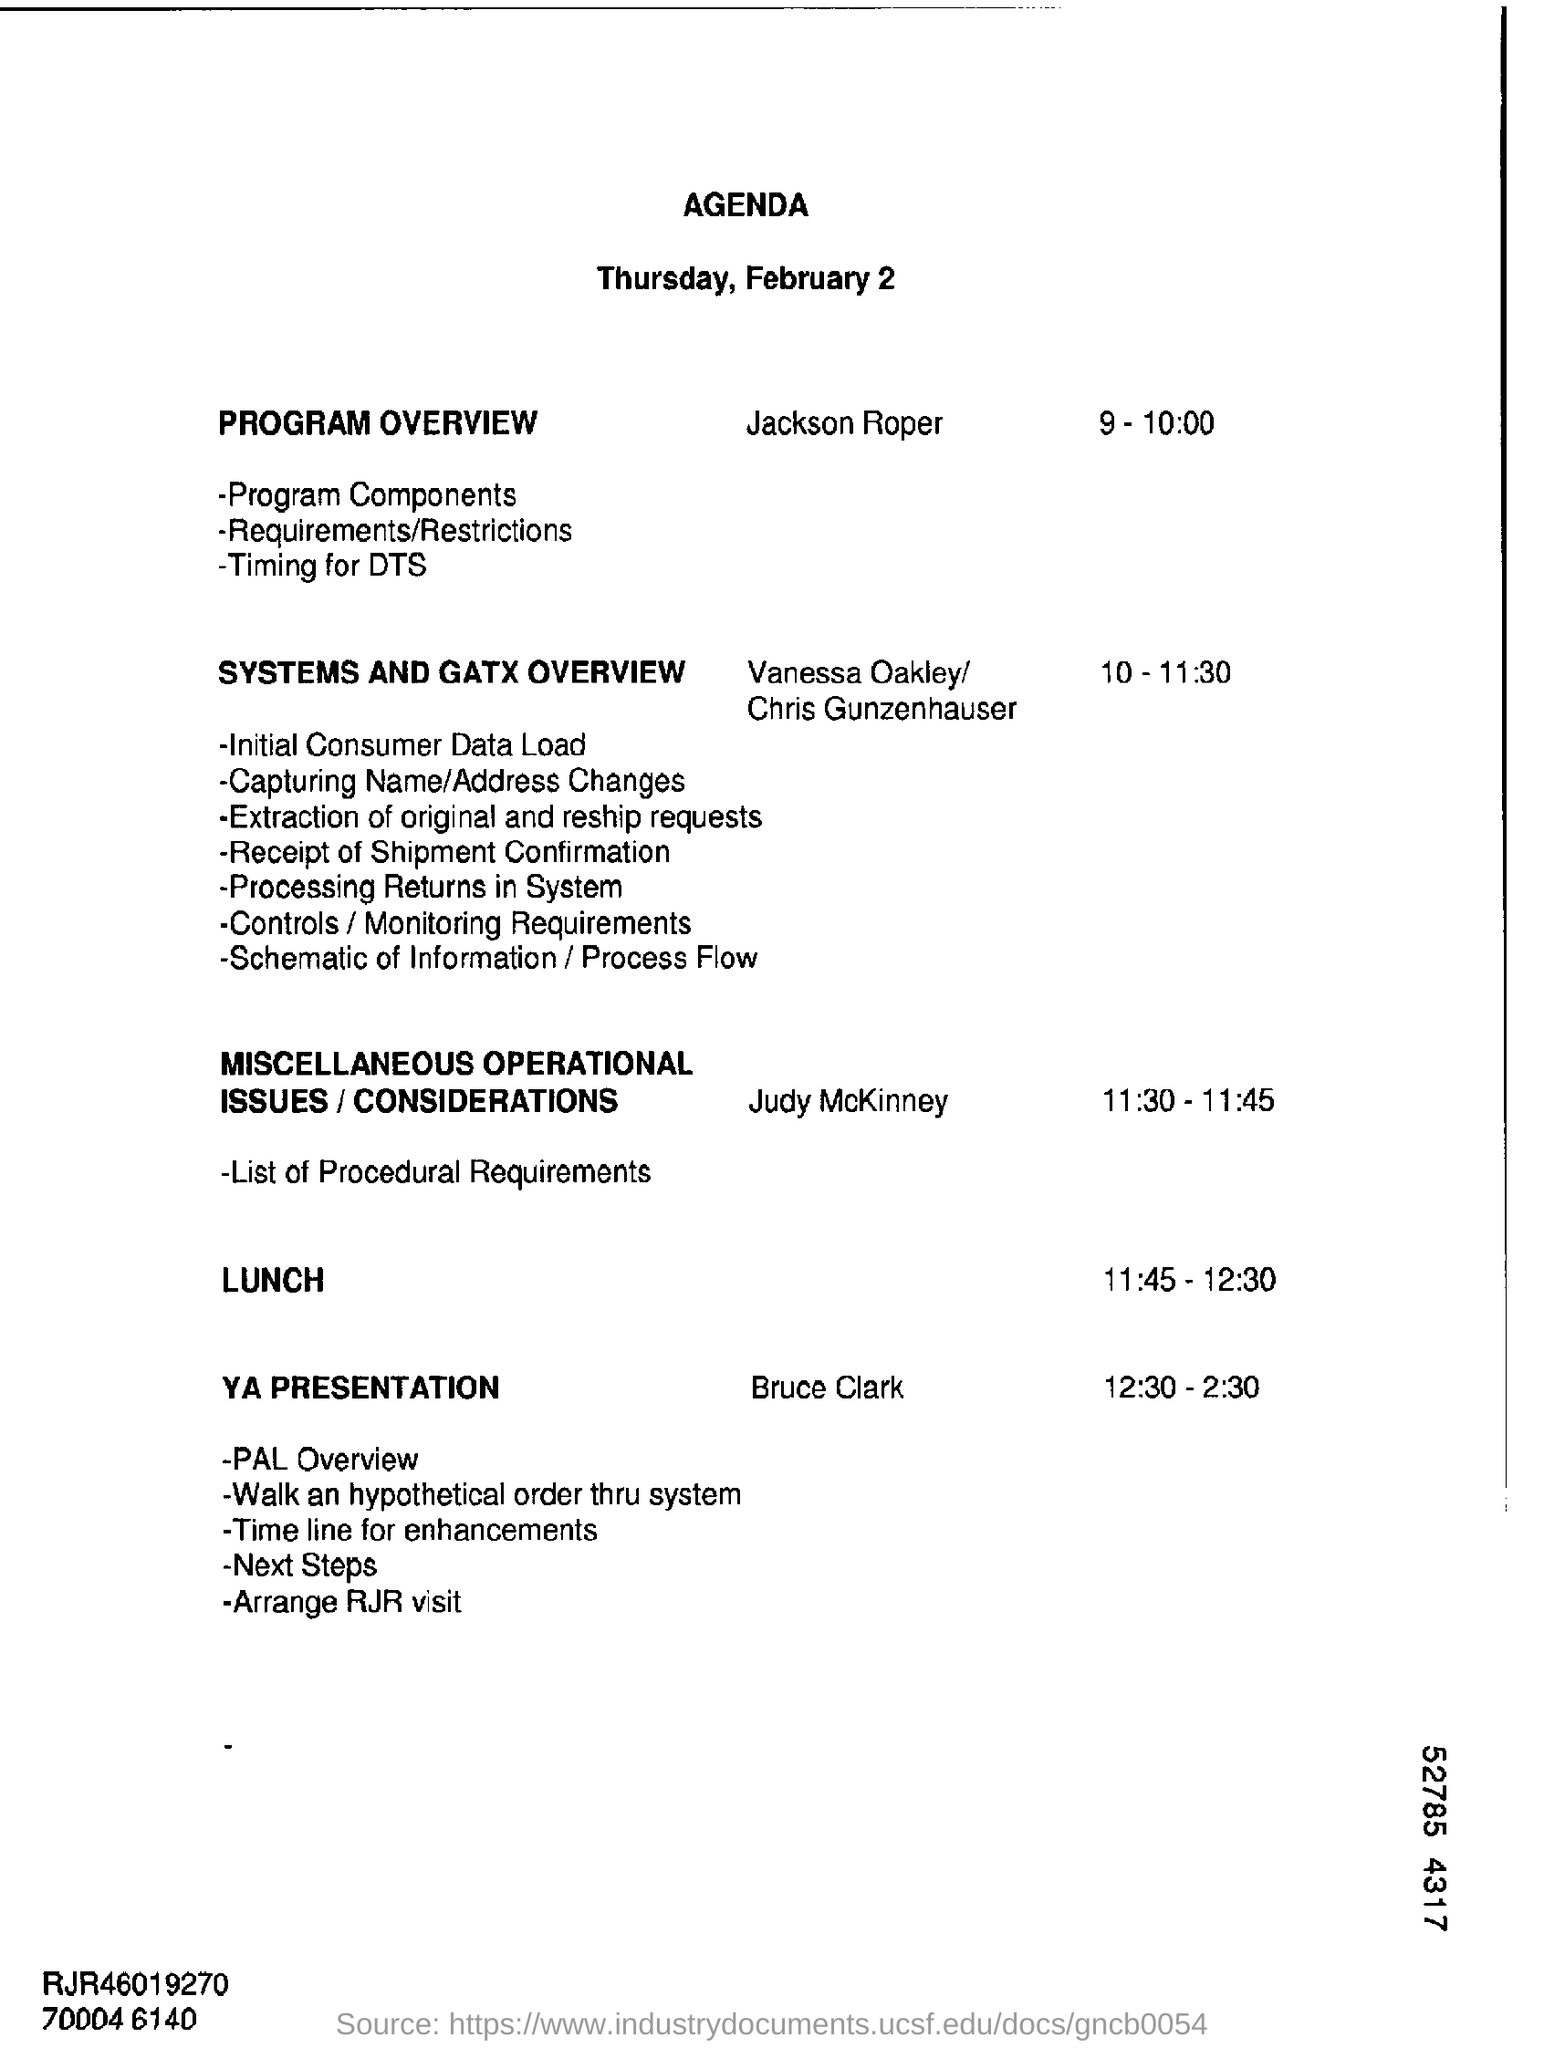Outline some significant characteristics in this image. The lunch time is from 11:45 to 12:30. The final session of the PROGRAM OVERVIEW is taking place, and the timing for the DTS has been established. The speaker is announcing that Jackson Roper is in charge of the program overview. The first event of the 'YA PRESENTATION' activity is the 'PAL OVERVIEW'. The PROGRAM OVERVIEW is allotted a time period of 9-10:00. 